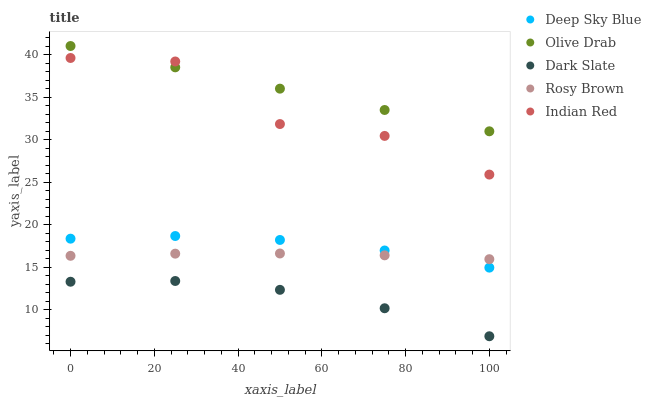Does Dark Slate have the minimum area under the curve?
Answer yes or no. Yes. Does Olive Drab have the maximum area under the curve?
Answer yes or no. Yes. Does Rosy Brown have the minimum area under the curve?
Answer yes or no. No. Does Rosy Brown have the maximum area under the curve?
Answer yes or no. No. Is Olive Drab the smoothest?
Answer yes or no. Yes. Is Indian Red the roughest?
Answer yes or no. Yes. Is Dark Slate the smoothest?
Answer yes or no. No. Is Dark Slate the roughest?
Answer yes or no. No. Does Dark Slate have the lowest value?
Answer yes or no. Yes. Does Rosy Brown have the lowest value?
Answer yes or no. No. Does Olive Drab have the highest value?
Answer yes or no. Yes. Does Rosy Brown have the highest value?
Answer yes or no. No. Is Deep Sky Blue less than Indian Red?
Answer yes or no. Yes. Is Olive Drab greater than Rosy Brown?
Answer yes or no. Yes. Does Olive Drab intersect Indian Red?
Answer yes or no. Yes. Is Olive Drab less than Indian Red?
Answer yes or no. No. Is Olive Drab greater than Indian Red?
Answer yes or no. No. Does Deep Sky Blue intersect Indian Red?
Answer yes or no. No. 